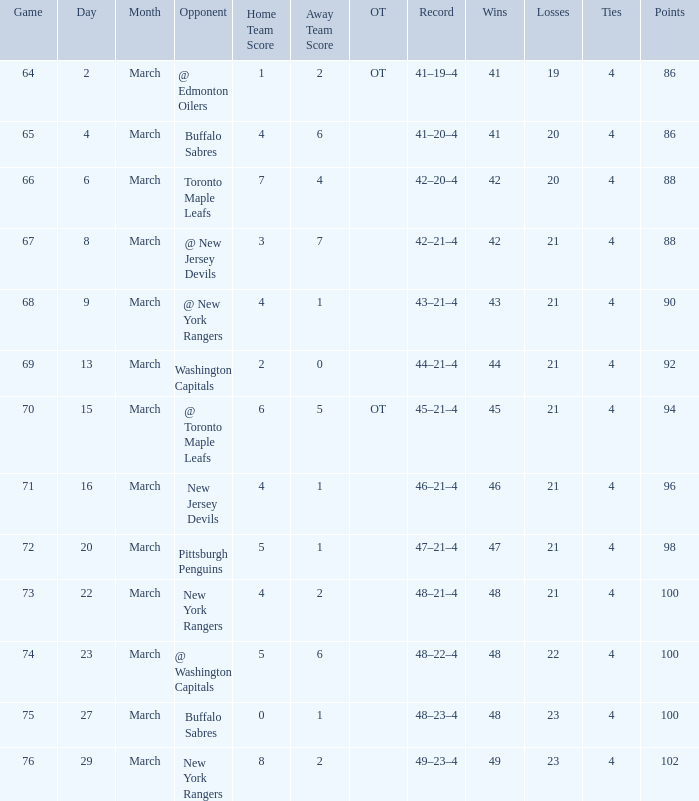Which competitor has a performance of 45-21-4? @ Toronto Maple Leafs. 